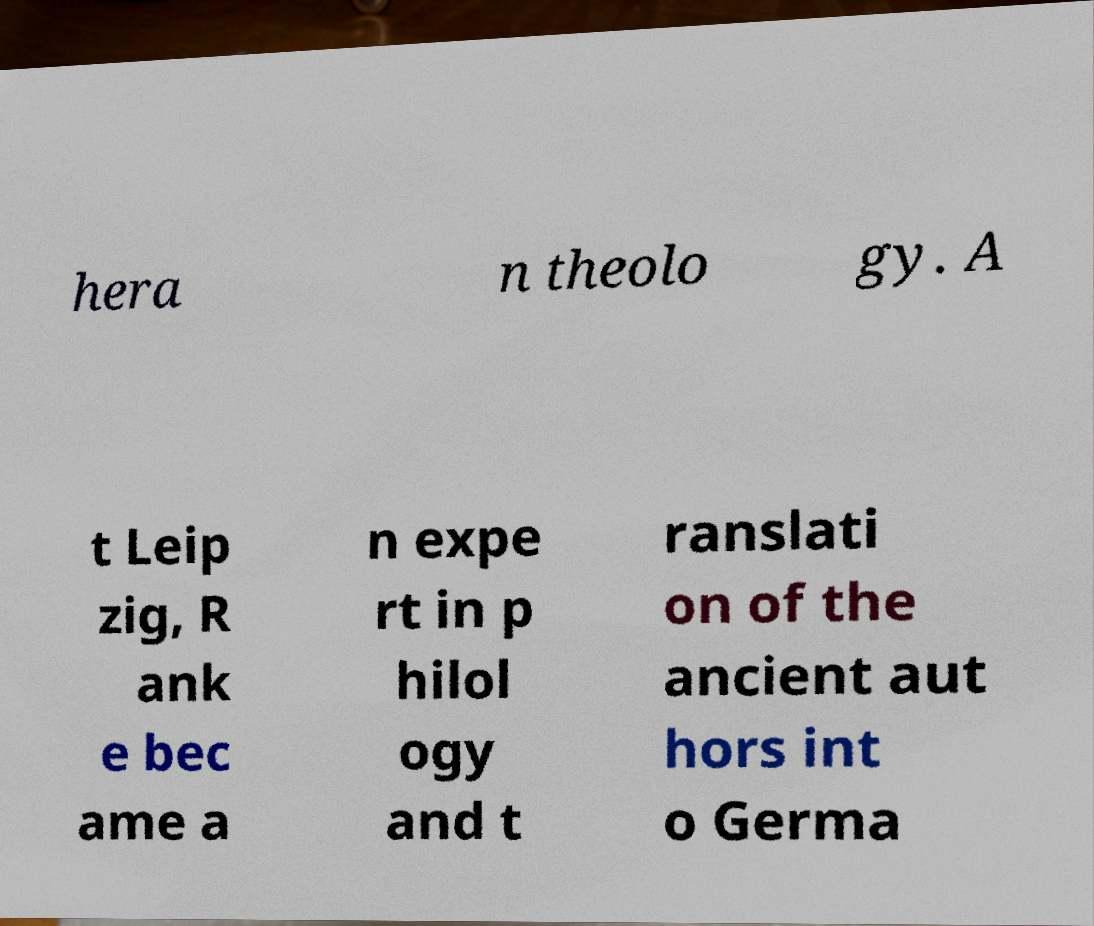Can you accurately transcribe the text from the provided image for me? hera n theolo gy. A t Leip zig, R ank e bec ame a n expe rt in p hilol ogy and t ranslati on of the ancient aut hors int o Germa 